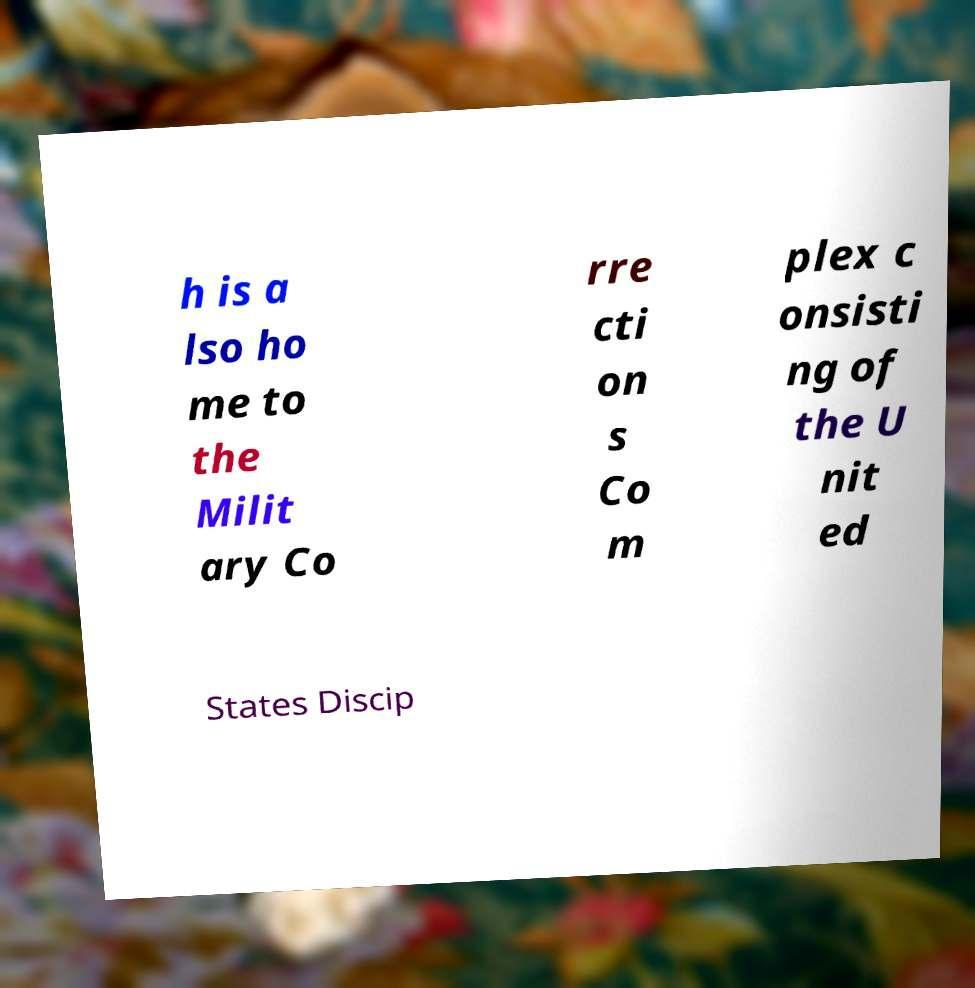Could you extract and type out the text from this image? h is a lso ho me to the Milit ary Co rre cti on s Co m plex c onsisti ng of the U nit ed States Discip 